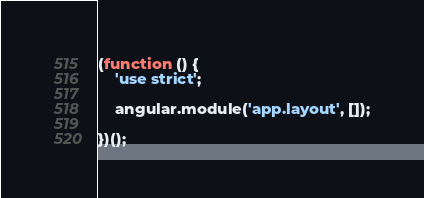Convert code to text. <code><loc_0><loc_0><loc_500><loc_500><_JavaScript_>(function () {
    'use strict';

    angular.module('app.layout', []);

})();</code> 